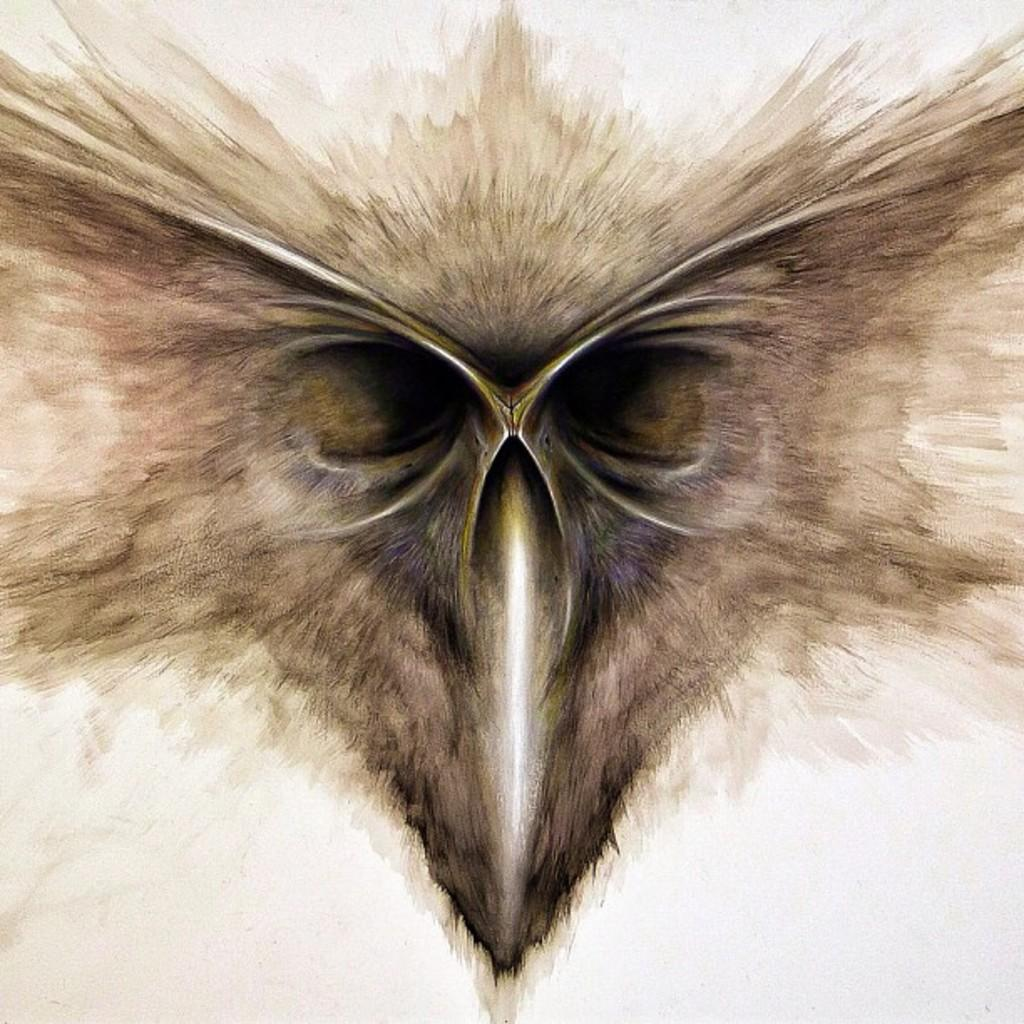What can be seen in the image related to birds? There are bird's eyes visible in the image. Can you describe the bird's eyes in more detail? Unfortunately, the provided facts do not offer more detail about the bird's eyes. Are there any other bird-related elements in the image? The facts only mention the bird's eyes, so there is no information about other bird-related elements. Is there a stream of water flowing near the bird's eyes in the image? There is no mention of a stream of water in the provided facts, so we cannot determine if there is one in the image. 